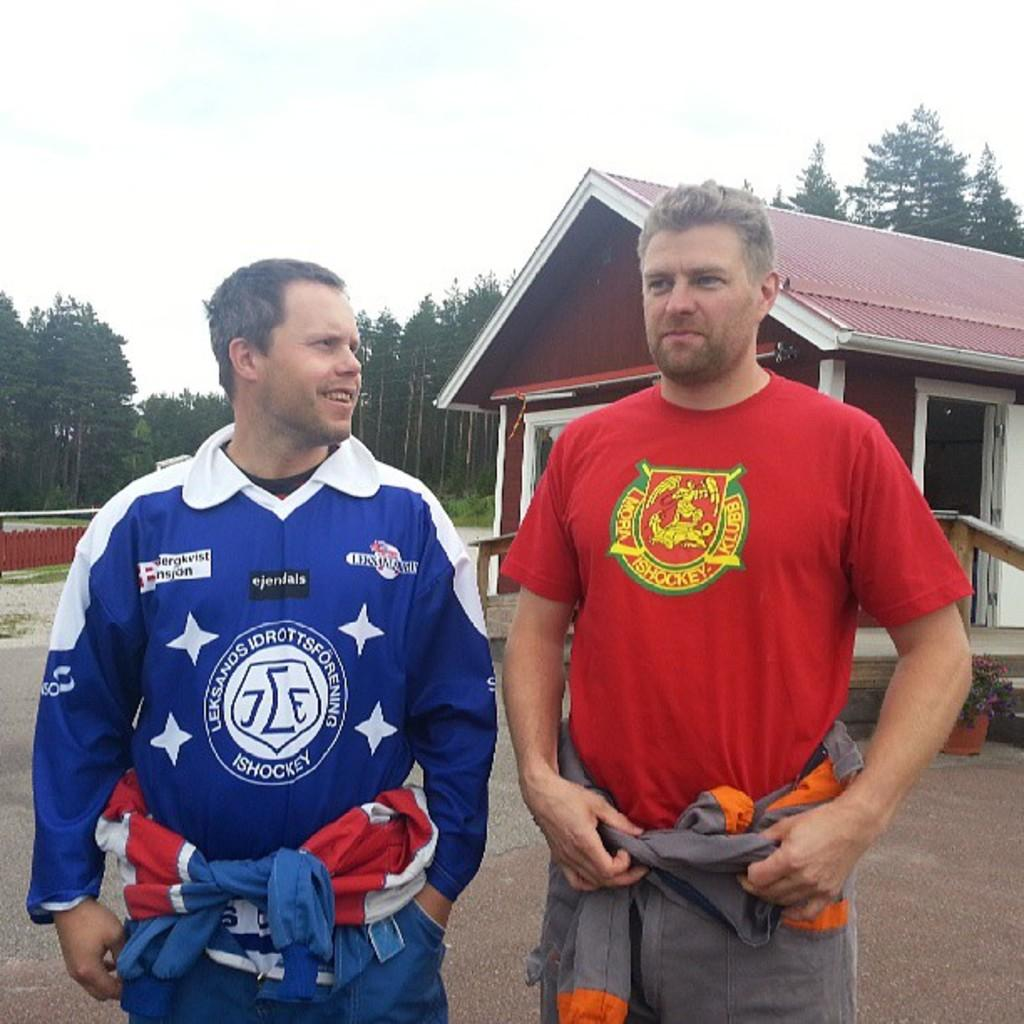<image>
Summarize the visual content of the image. two guys with one wearing a red hockey shirt 